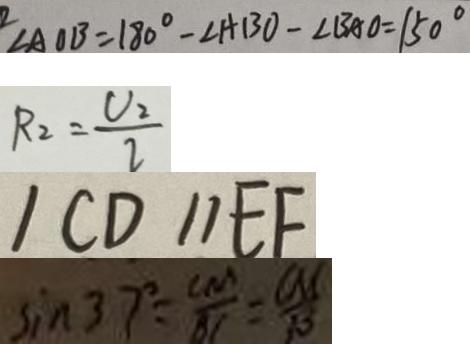Convert formula to latex. <formula><loc_0><loc_0><loc_500><loc_500>\angle A O B = 1 8 0 ^ { \circ } - \angle A B O - \angle B A O = 1 5 0 ^ { \circ } 
 R _ { 2 } = \frac { V _ { 2 } } { I } 
 / C D / / E F 
 \sin 3 7 ^ { \circ } = \frac { C M } { B C } = \frac { C M } { 1 0 }</formula> 